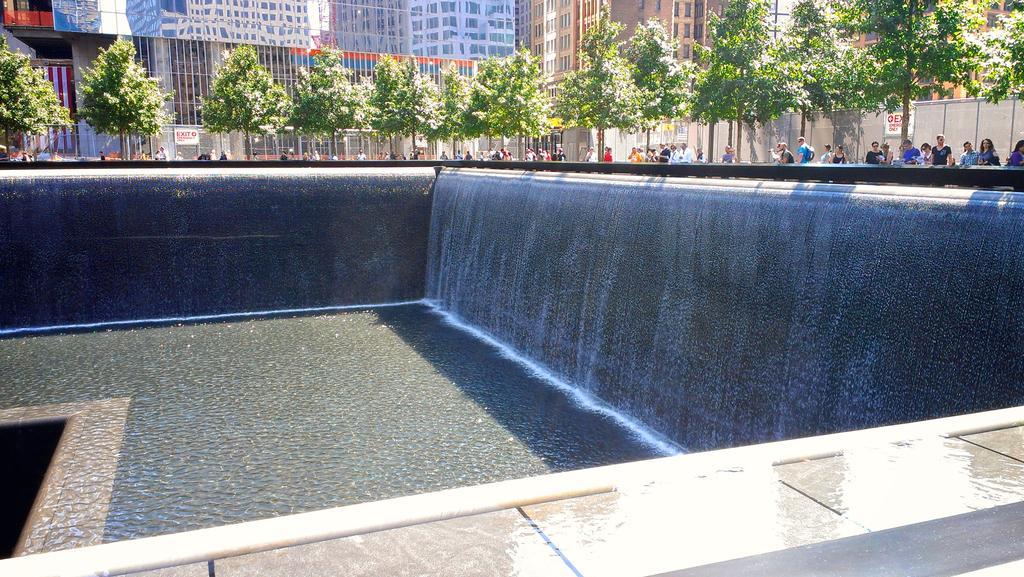How would you summarize this image in a sentence or two? In this image we can see the structure which looks like a memorial plaza and there are some people standing. We can see some trees and at the top of the image we can see some buildings. 